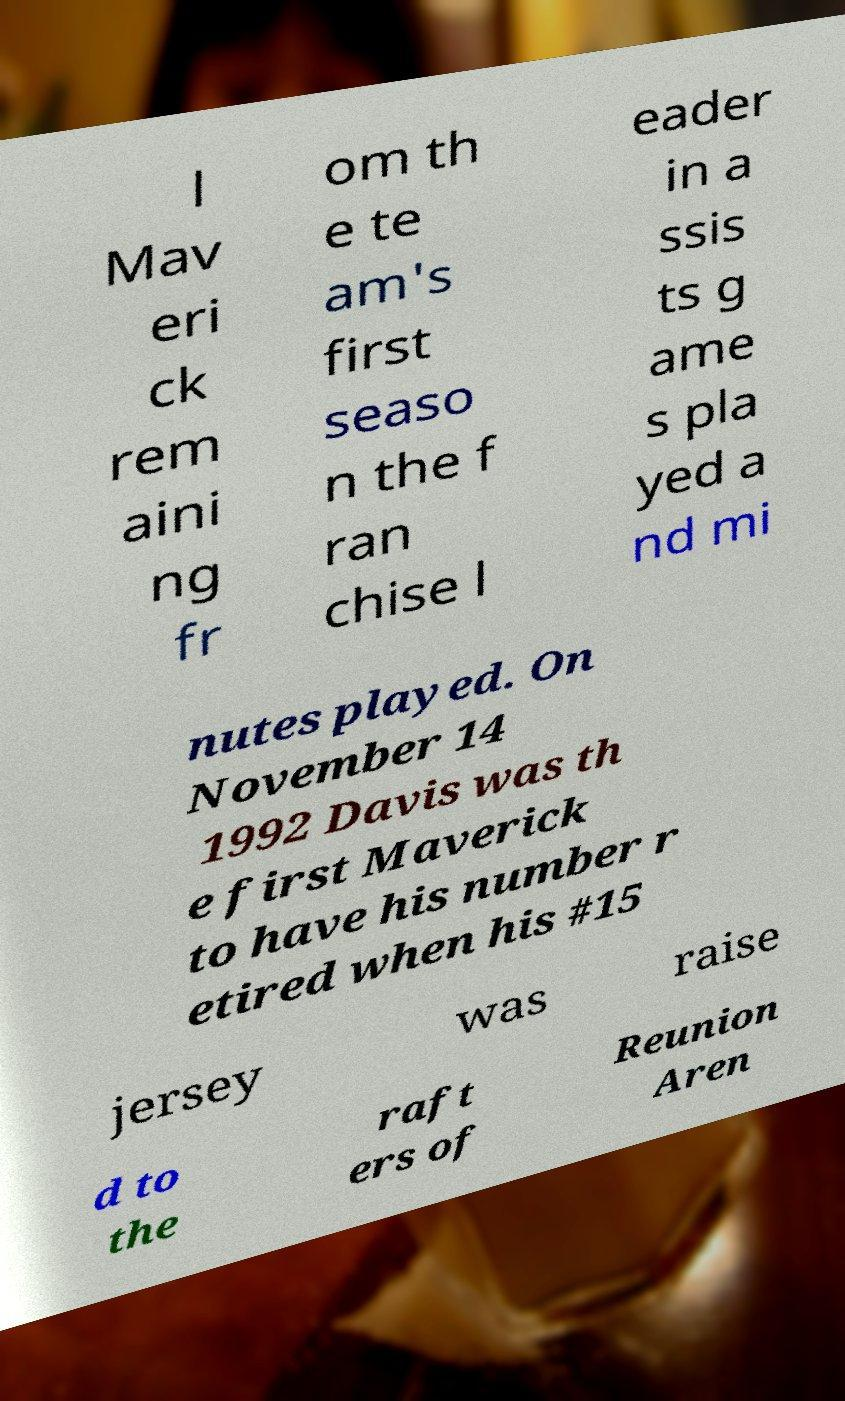Please identify and transcribe the text found in this image. l Mav eri ck rem aini ng fr om th e te am's first seaso n the f ran chise l eader in a ssis ts g ame s pla yed a nd mi nutes played. On November 14 1992 Davis was th e first Maverick to have his number r etired when his #15 jersey was raise d to the raft ers of Reunion Aren 